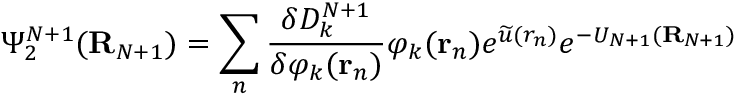<formula> <loc_0><loc_0><loc_500><loc_500>\Psi _ { 2 } ^ { N + 1 } ( { R } _ { N + 1 } ) = \sum _ { n } \frac { \delta D _ { k } ^ { N + 1 } } { \delta \varphi _ { k } ( { r } _ { n } ) } \varphi _ { k } ( { r } _ { n } ) e ^ { \widetilde { u } ( r _ { n } ) } e ^ { - U _ { N + 1 } ( { R } _ { N + 1 } ) }</formula> 